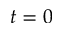<formula> <loc_0><loc_0><loc_500><loc_500>t = 0</formula> 